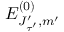Convert formula to latex. <formula><loc_0><loc_0><loc_500><loc_500>E _ { J _ { \tau ^ { \prime } } ^ { \prime } , m ^ { \prime } } ^ { ( 0 ) }</formula> 